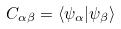<formula> <loc_0><loc_0><loc_500><loc_500>C _ { \alpha \beta } = \langle \psi _ { \alpha } | \psi _ { \beta } \rangle</formula> 